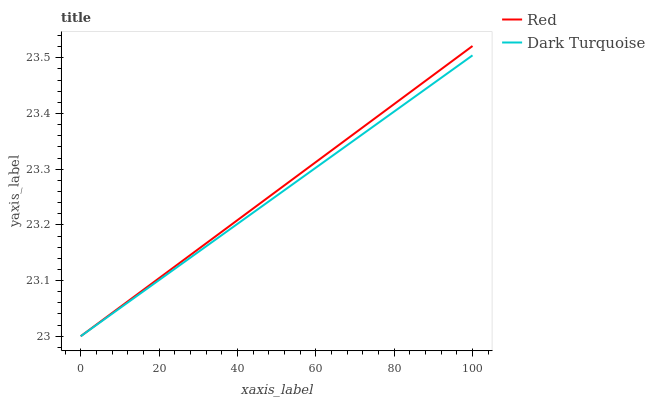Does Red have the minimum area under the curve?
Answer yes or no. No. Is Red the smoothest?
Answer yes or no. No. 